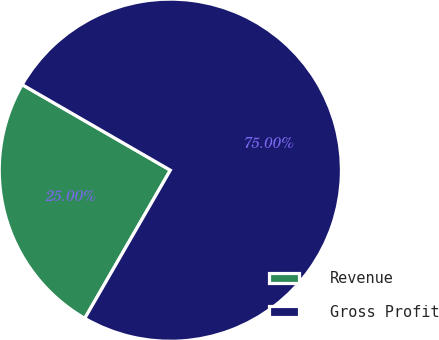Convert chart. <chart><loc_0><loc_0><loc_500><loc_500><pie_chart><fcel>Revenue<fcel>Gross Profit<nl><fcel>25.0%<fcel>75.0%<nl></chart> 